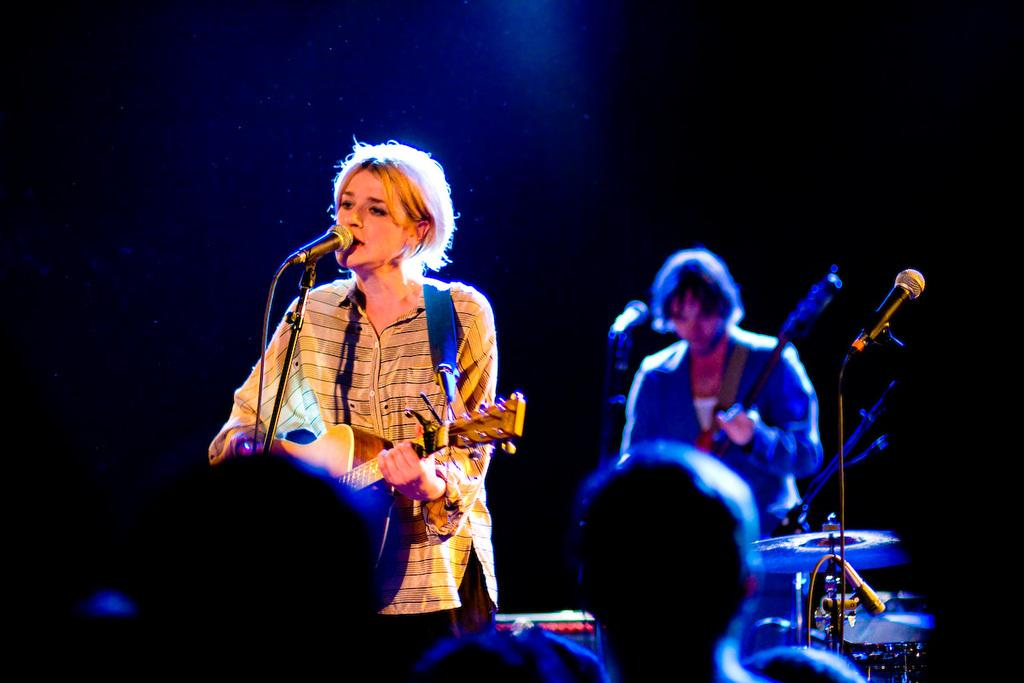What is the woman in the image doing? The woman is singing on a mic and playing a guitar. What is the man in the image doing? The man is playing a guitar. Can you describe the people in front of the woman and man? There are people in front of the woman and man, but their specific actions or appearances are not mentioned in the facts. What is the purpose of the low picture frame in the image? There is no mention of a low picture frame in the image, so it cannot be determined if it serves a purpose or not. 